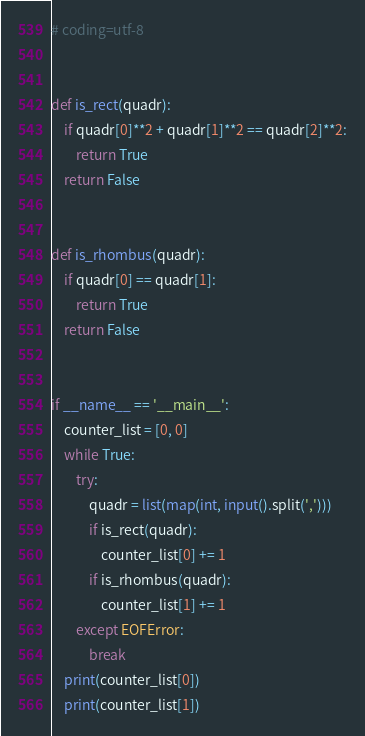<code> <loc_0><loc_0><loc_500><loc_500><_Python_># coding=utf-8


def is_rect(quadr):
    if quadr[0]**2 + quadr[1]**2 == quadr[2]**2:
        return True
    return False


def is_rhombus(quadr):
    if quadr[0] == quadr[1]:
        return True
    return False


if __name__ == '__main__':
    counter_list = [0, 0]
    while True:
        try:
            quadr = list(map(int, input().split(',')))
            if is_rect(quadr):
                counter_list[0] += 1
            if is_rhombus(quadr):
                counter_list[1] += 1
        except EOFError:
            break
    print(counter_list[0])
    print(counter_list[1])

</code> 